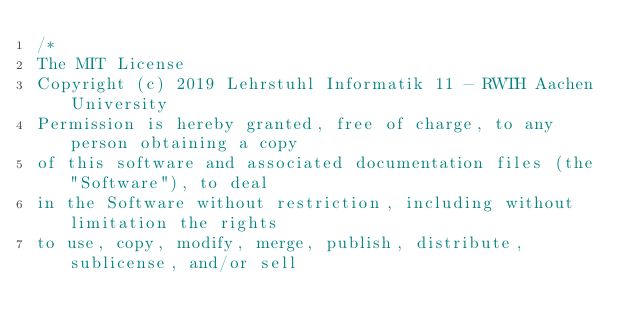Convert code to text. <code><loc_0><loc_0><loc_500><loc_500><_C++_>/*
The MIT License
Copyright (c) 2019 Lehrstuhl Informatik 11 - RWTH Aachen University
Permission is hereby granted, free of charge, to any person obtaining a copy
of this software and associated documentation files (the "Software"), to deal
in the Software without restriction, including without limitation the rights
to use, copy, modify, merge, publish, distribute, sublicense, and/or sell</code> 